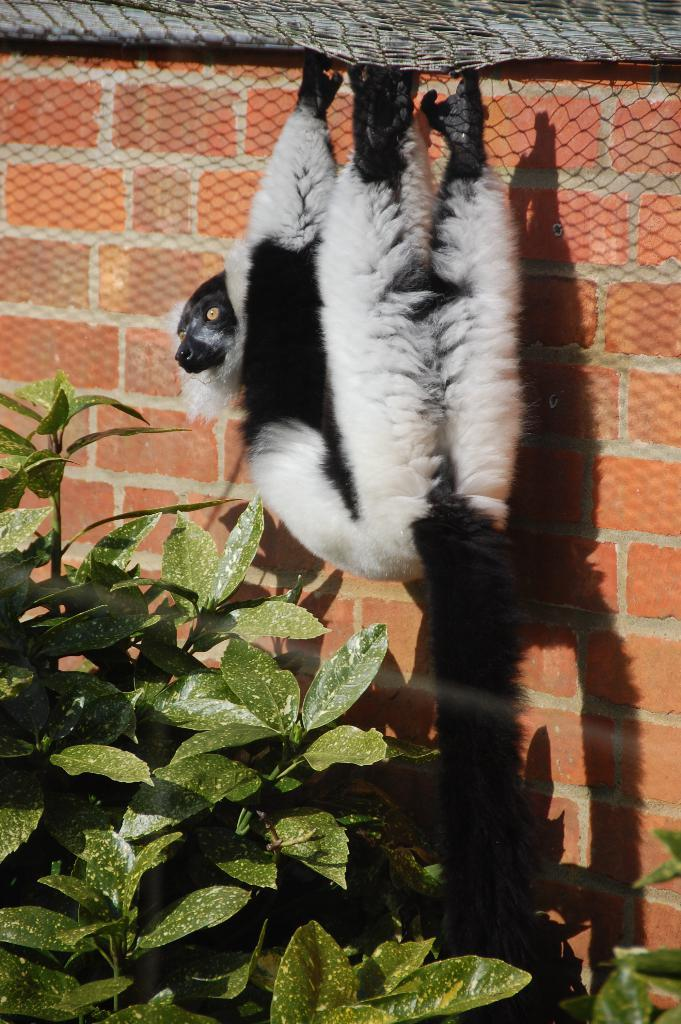What type of living organism can be seen in the image? There is a plant in the image. What is the material of the wall in the image? The wall in the image is made of bricks. What is attached to the wall in the image? There is a net attached to the wall in the image. What is the monkey doing in the image? A monkey is hanging from the net in the image. What type of treatment is the monkey receiving from the doctor in the image? There is no doctor or treatment present in the image; it features a monkey hanging from a net attached to a brick wall. How many times does the monkey sneeze in the image? There is no sneezing or indication of a medical condition in the image; the monkey is simply hanging from the net. 